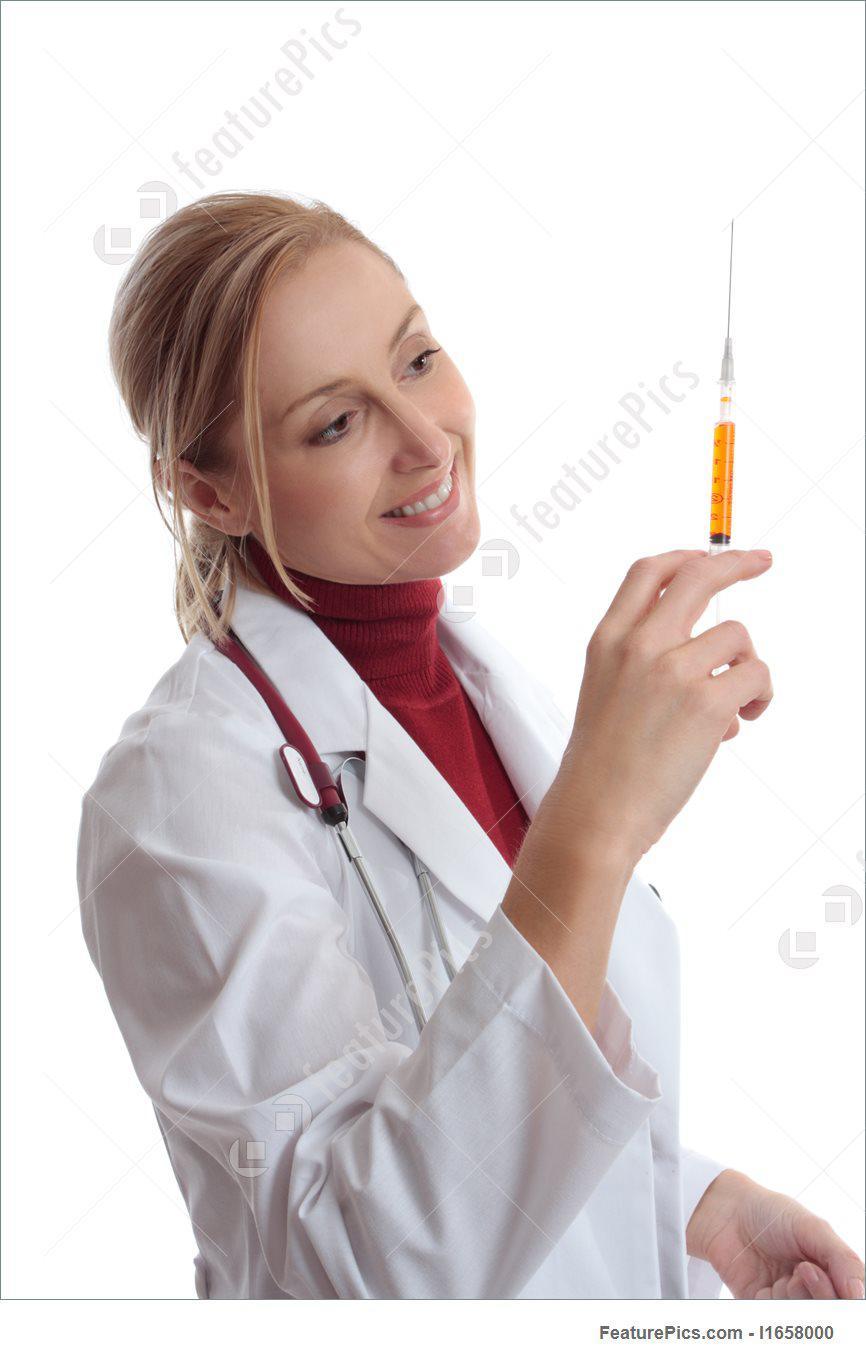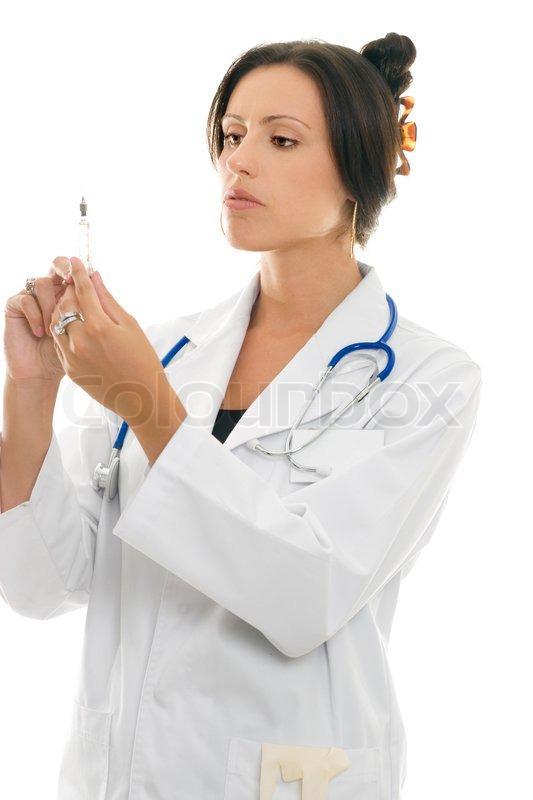The first image is the image on the left, the second image is the image on the right. Given the left and right images, does the statement "Two women are holding syringes." hold true? Answer yes or no. Yes. The first image is the image on the left, the second image is the image on the right. Evaluate the accuracy of this statement regarding the images: "A person is holding a hypdermic needle in a gloved hand in one image.". Is it true? Answer yes or no. No. 